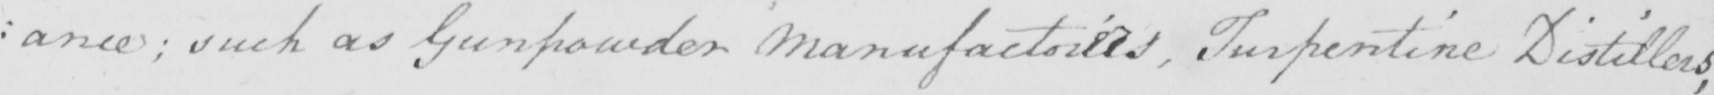What text is written in this handwritten line? : ance ; such as Gunpowder Manufactories , Turpentine Distillers , 